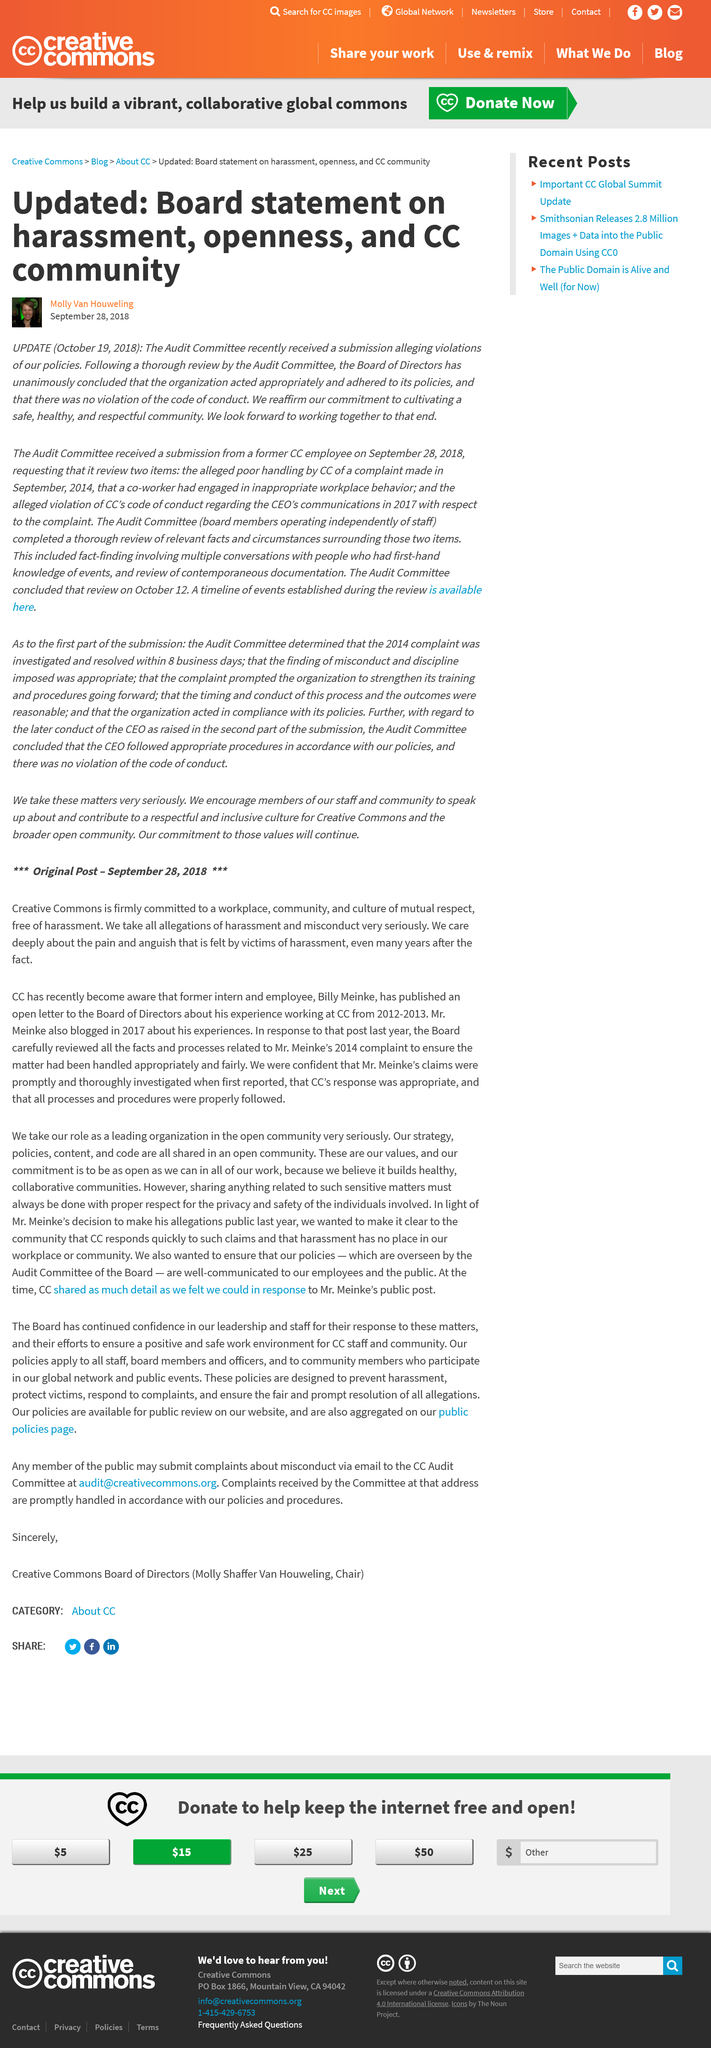Give some essential details in this illustration. The Audit Committee received the allegations of policy violations. The board is committed to cultivating a community that is safe, healthy, and respectful. The article was last updated one month after it was originally written. 